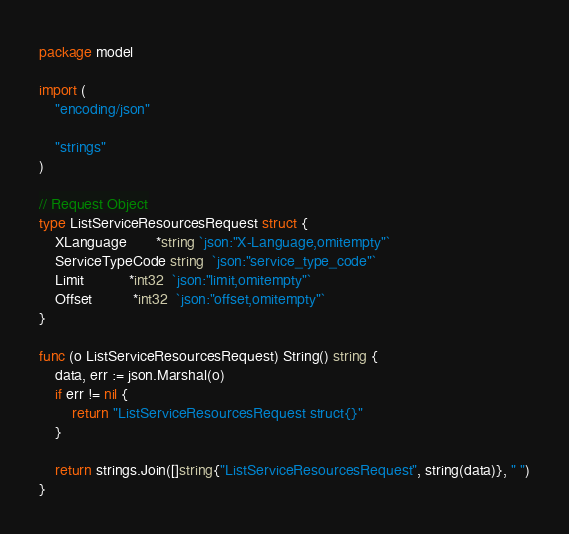Convert code to text. <code><loc_0><loc_0><loc_500><loc_500><_Go_>package model

import (
	"encoding/json"

	"strings"
)

// Request Object
type ListServiceResourcesRequest struct {
	XLanguage       *string `json:"X-Language,omitempty"`
	ServiceTypeCode string  `json:"service_type_code"`
	Limit           *int32  `json:"limit,omitempty"`
	Offset          *int32  `json:"offset,omitempty"`
}

func (o ListServiceResourcesRequest) String() string {
	data, err := json.Marshal(o)
	if err != nil {
		return "ListServiceResourcesRequest struct{}"
	}

	return strings.Join([]string{"ListServiceResourcesRequest", string(data)}, " ")
}
</code> 